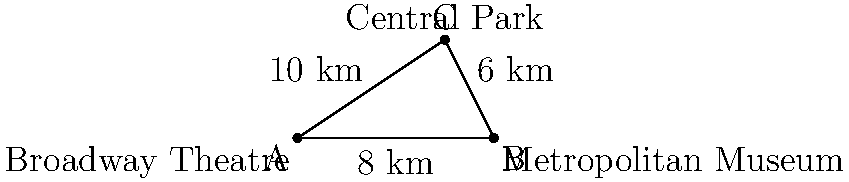As a costume designer seeking inspiration from New York City's landmarks, you're planning a route between three iconic locations: the Broadway Theatre, the Metropolitan Museum, and Central Park. On your map, the distance between the Broadway Theatre and the Metropolitan Museum is 8 km, and the distance from the Metropolitan Museum to Central Park is 6 km. If the direct route from the Broadway Theatre to Central Park is 10 km, what is the angle (in degrees, rounded to the nearest whole number) between the Broadway Theatre-Metropolitan Museum line and the Broadway Theatre-Central Park line? Let's approach this step-by-step using the law of cosines:

1) Let's define our triangle:
   A: Broadway Theatre
   B: Metropolitan Museum
   C: Central Park

2) We know:
   AB = 8 km
   BC = 6 km
   AC = 10 km

3) The law of cosines states:
   $$ c^2 = a^2 + b^2 - 2ab \cos(C) $$
   where C is the angle we're looking for.

4) Plugging in our values:
   $$ 10^2 = 8^2 + 6^2 - 2(8)(6) \cos(C) $$

5) Simplify:
   $$ 100 = 64 + 36 - 96 \cos(C) $$

6) Solve for $\cos(C)$:
   $$ 100 = 100 - 96 \cos(C) $$
   $$ 0 = -96 \cos(C) $$
   $$ \cos(C) = 0 $$

7) To find C, we need to take the inverse cosine (arccos):
   $$ C = \arccos(0) $$

8) Calculate:
   $$ C \approx 90^\circ $$

Therefore, the angle between the Broadway Theatre-Metropolitan Museum line and the Broadway Theatre-Central Park line is approximately 90 degrees.
Answer: 90° 